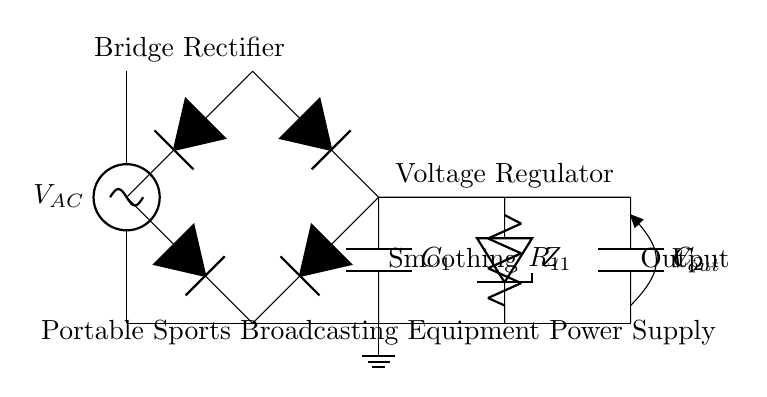What type of rectifier is used in this circuit? The circuit uses a bridge rectifier, which is indicated by the arrangement of four diodes connected in a specific configuration to convert AC to DC.
Answer: bridge rectifier What component smooths the output voltage? The smoothing capacitor, labeled C1 in the diagram, serves to reduce the fluctuations in the rectified output voltage, providing a more stable DC supply.
Answer: C1 How many diodes are present in the bridge rectifier? The bridge rectifier consists of four diodes, which are necessary to achieve full-wave rectification from the AC input.
Answer: four diodes What is the function of the voltage regulator? The voltage regulator stabilizes the output voltage by maintaining a constant voltage level despite variations in input voltage or load conditions.
Answer: stabilizes voltage What is the output voltage of the circuit? The output voltage, labeled as V_out in the diagram, represents the processed output from the power supply, which is expected to be steady and usable for the sports broadcasting equipment.
Answer: V_out Why is a grounding point shown in the circuit? The ground point in the circuit provides a common return path for the electrical current and establishes a reference point for the voltages within the circuit.
Answer: common ground 